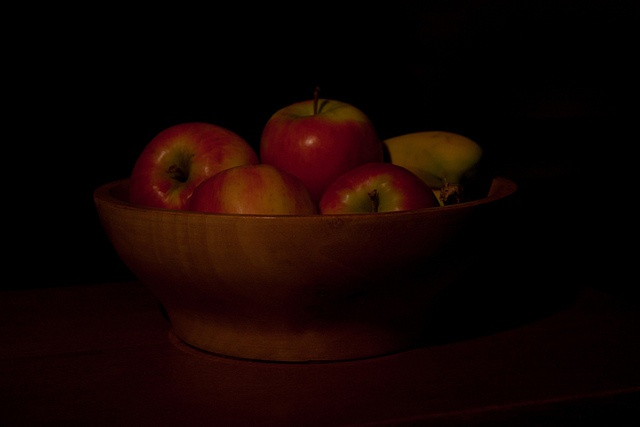Describe the objects in this image and their specific colors. I can see bowl in black, maroon, and brown tones, apple in black, maroon, and brown tones, apple in black, maroon, and brown tones, and apple in black and maroon tones in this image. 